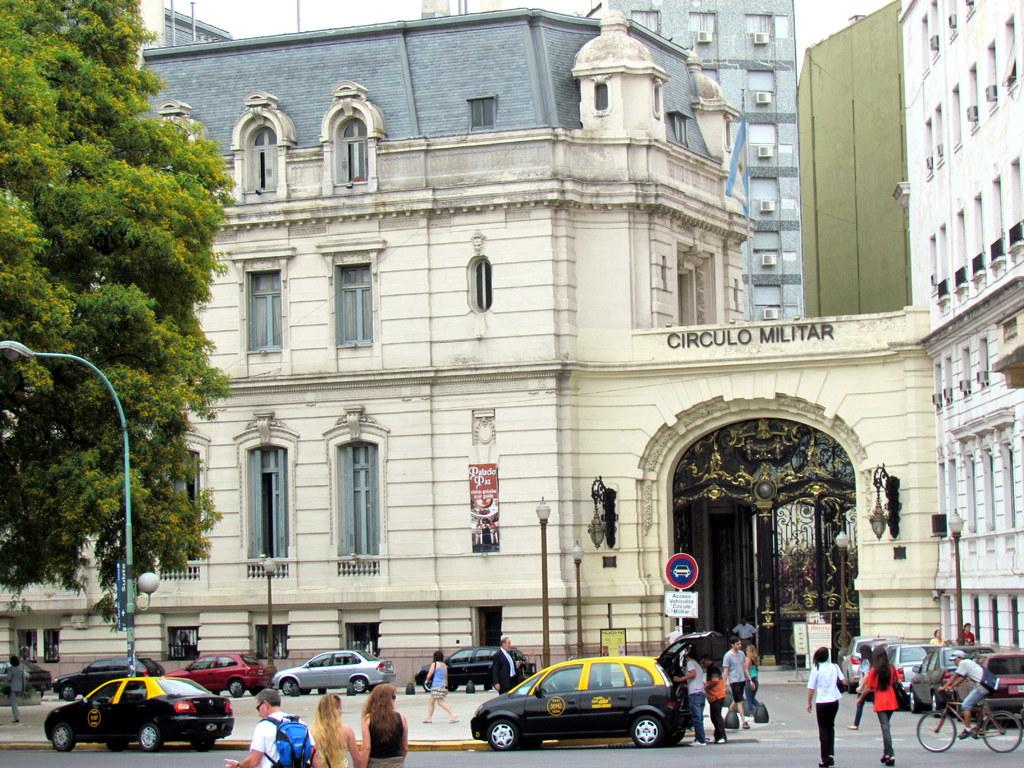<image>
Summarize the visual content of the image. a building that has circulo written on the building 